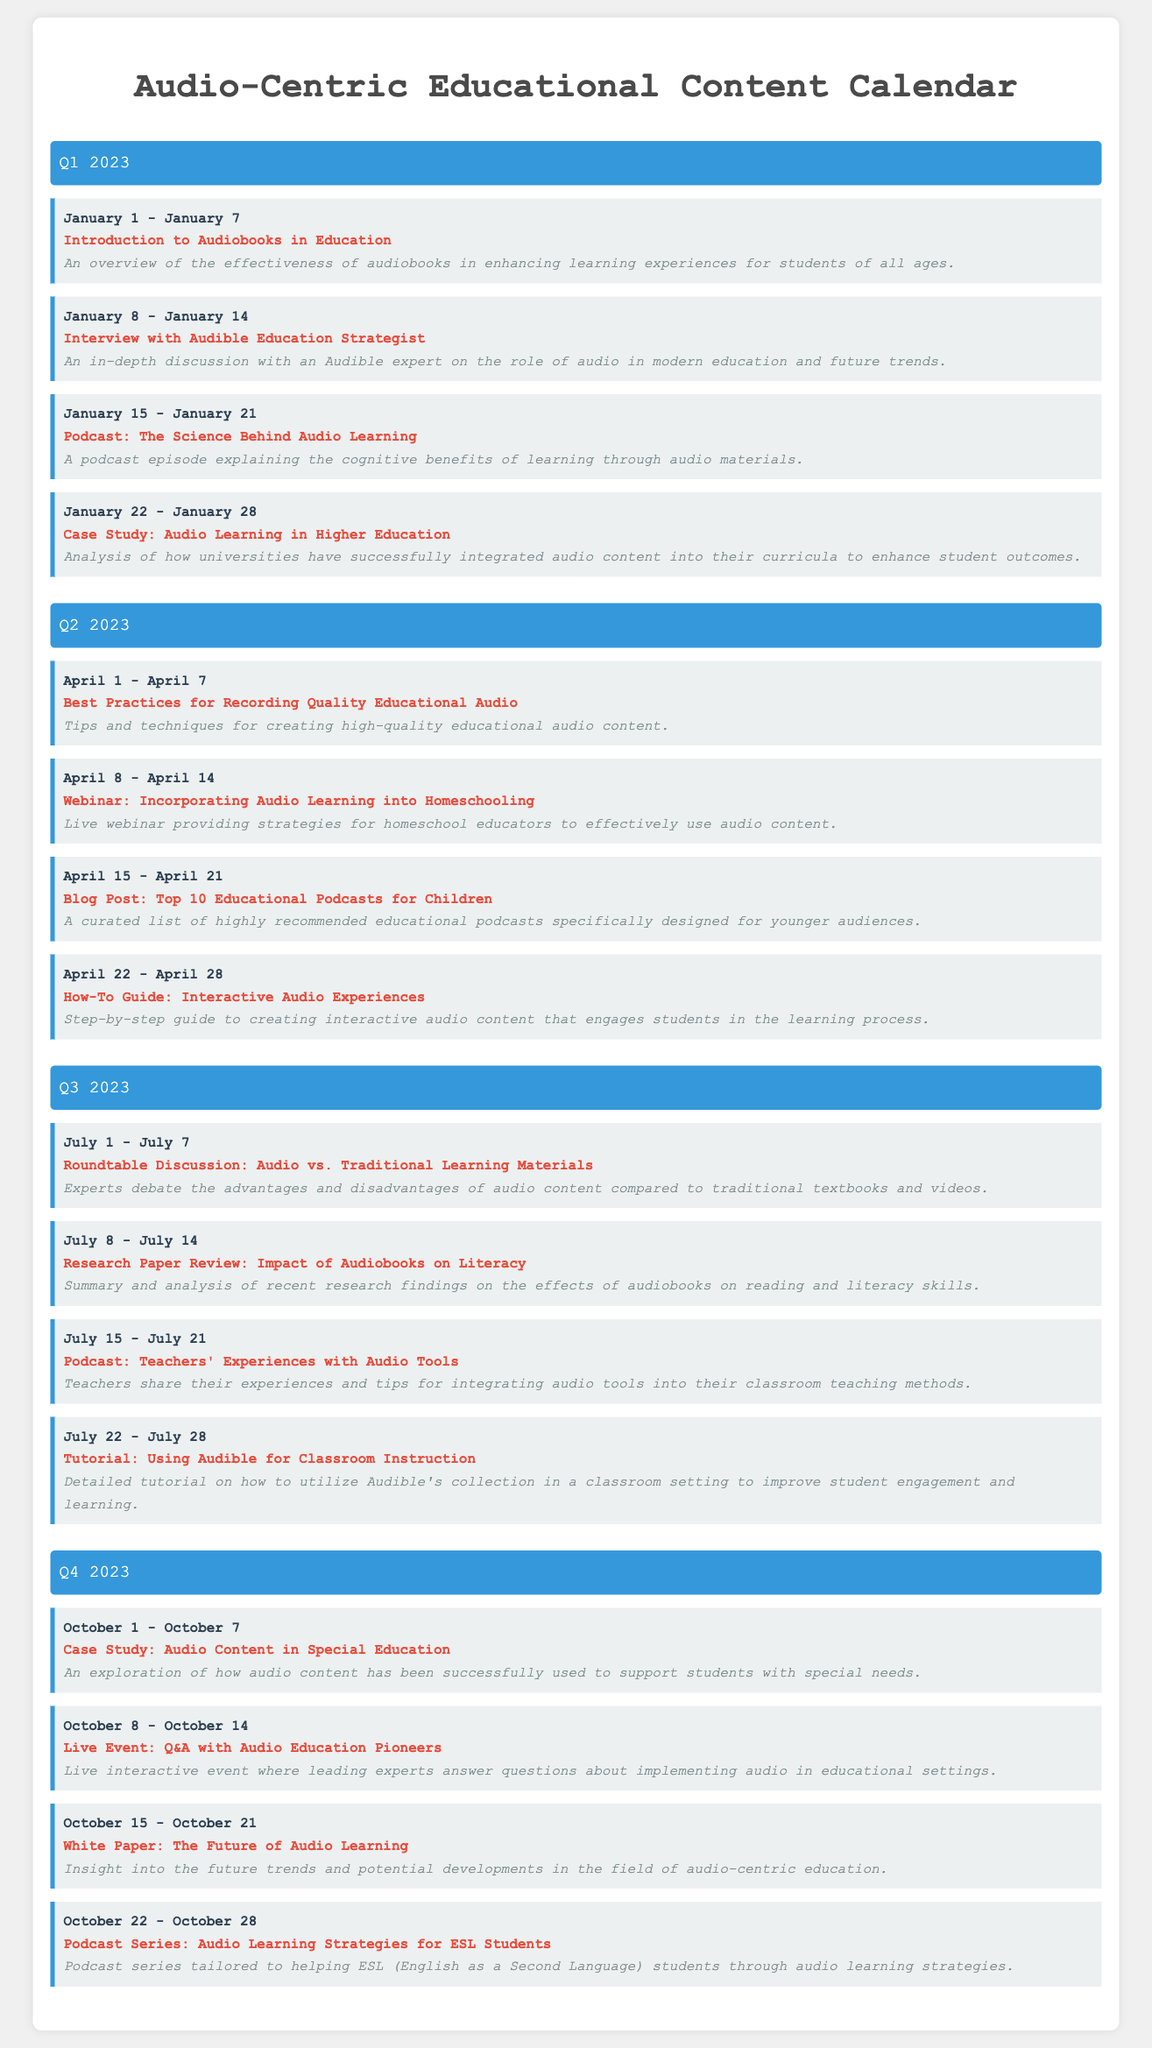what is the title of the document? The title is prominently displayed at the top of the document and states the focus of the content.
Answer: Audio-Centric Educational Content Calendar how many weeks are listed in Q1 2023? Each quarter contains multiple weeks, and this specific quarter has four defined weeks.
Answer: 4 what is the content name for the week of April 15 - April 21? The specific week in April has a content name provided within the details of that week.
Answer: Blog Post: Top 10 Educational Podcasts for Children what type of event is planned for October 8 - October 14? The document clearly categorizes the planned activity for that week, indicating its nature as an interactive gathering.
Answer: Live Event which month does the "Podcast Series: Audio Learning Strategies for ESL Students" occur? The week listed provides the month in which this series is scheduled, indicating when it will be available to the audience.
Answer: October what is the focus of the case study in Q4 2023? The description summarizes the main subject matter of the case study in that quarter, highlighting its specific educational context.
Answer: Audio Content in Special Education how many quarters are included in this calendar? The document specifies the structure and number of quarters, each containing several weeks of content.
Answer: 4 who is the expert interviewed in Q1 2023? The document states the type of expert featured in the interview during the first quarter, offering insight into the content.
Answer: Audible Education Strategist what is the publication format of the content scheduled for Q2 2023, April 1 - April 7? The document specifies the format of the content planned for that week, relating to audio content creation.
Answer: How-To Guide 